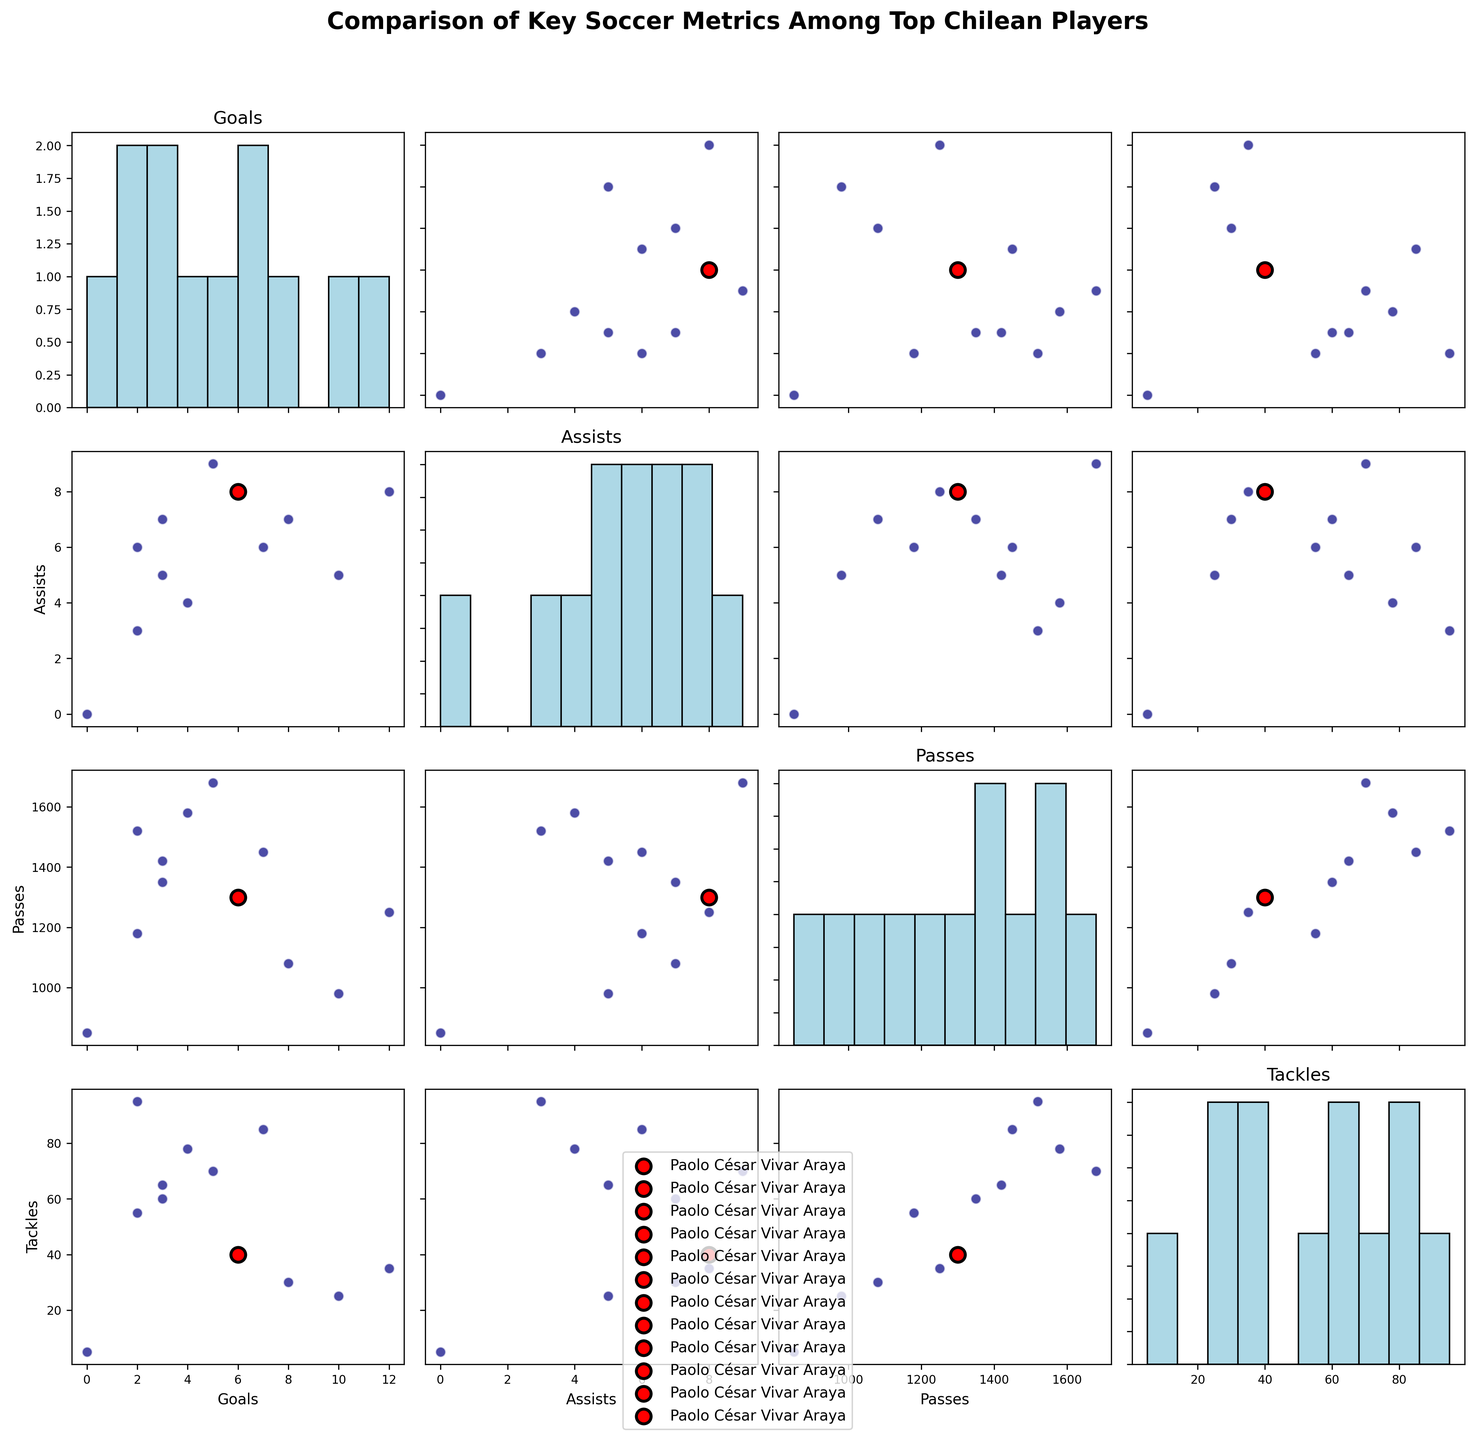What is the title of the figure? The title is typically displayed at the top of the plot. It is intended to provide a summary of what the plot represents.
Answer: Comparison of Key Soccer Metrics Among Top Chilean Players Which metric appears on the x-axis when comparing Goals to Assists? In a scatterplot matrix, the x-axis is determined by the column metric and the y-axis by the row metric. For this comparison, Goals are on the y-axis, and Assists are on the x-axis.
Answer: Assists How many goals did Paolo César Vivar Araya score? By identifying the color legend, Paolo César Vivar Araya's data points are highlighted in red. His goal count can be observed in the scatterplot or by reading the metric histogram.
Answer: 6 Which player has the highest number of tackles? Tackle data is visually represented, and the maximum value can be identified by looking at the top point in the Tackles histogram or scatterplots involving Tackles.
Answer: Gary Medel Is there any player who scored zero goals? The histograms or scatterplots involving Goals show values. Observing closely, Claudio Bravo's data point indicates zero goals scored.
Answer: Claudio Bravo Who has more assists: Alexis Sánchez or Charles Aránguiz? To determine the number of assists, reference the assists column in the data or visualize the specific point distributions in the scatterplots involving Assists.
Answer: Charles Aránguiz How does the number of passes by Paolo César Vivar Araya compare to Alexis Sánchez? The scatterplots showing Passes data points for both players in relation to other metrics can be used to compare their Pass numbers. Paolo César Vivar Araya is marked in red.
Answer: Paolo César Vivar Araya has more passes than Alexis Sánchez Which player has the least number of goals and who has the most passes? By looking at the extreme points in the goals and passes histograms respectively, and cross-referencing these points with the scatterplot providing context.
Answer: Claudio Bravo has the least goals and Charles Aránguiz has the most passes Is there any correlation between tackles and passes for Paolo César Vivar Araya? To assess correlation, identify Paolo's (red point) position across scatterplots of Passes vs. Tackles and fit a trendline if necessary for interpreting their relationship.
Answer: There is no strong correlation Are there more players with fewer than 5 goals or with more than 7 assists? By examining the histograms directly or by counting points below 5 on the Goals axis vs. points above 7 on the Assists axis.
Answer: More players have fewer than 5 goals 